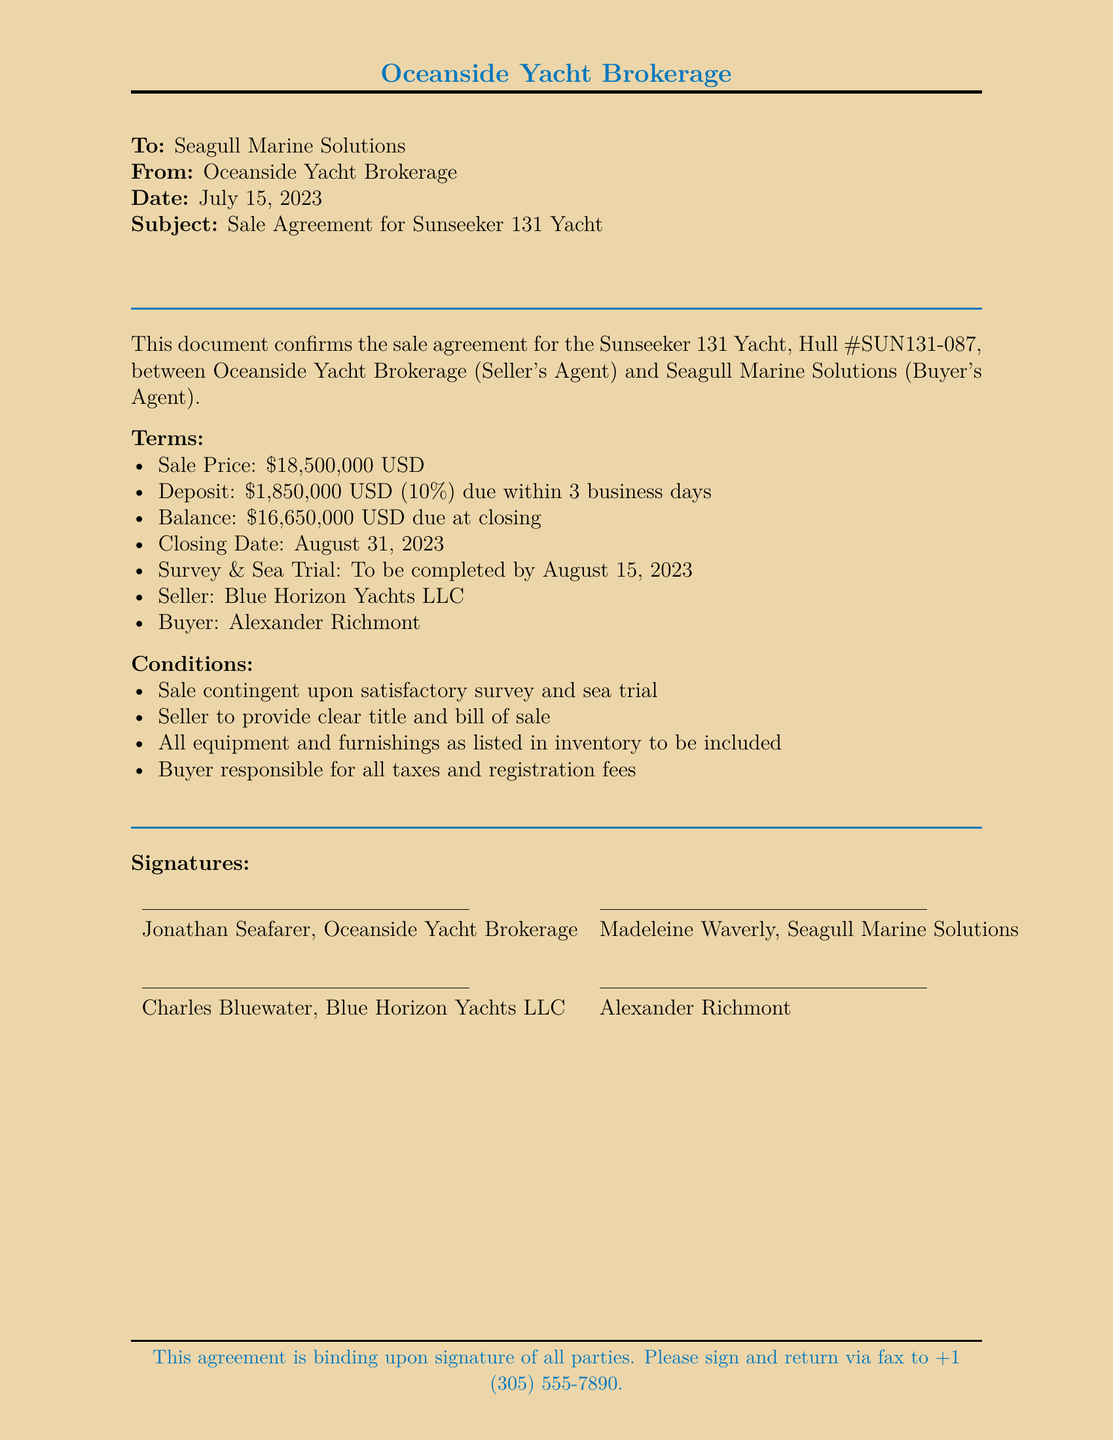What is the sale price of the yacht? The sale price is explicitly stated in the terms of the agreement as the total amount for the vessel, which is $18,500,000 USD.
Answer: $18,500,000 USD What is the deposit amount? The deposit amount is mentioned in the terms as 10% of the sale price, which totals $1,850,000 USD.
Answer: $1,850,000 USD Who is the seller's representative? The document lists Jonathan Seafarer as the representative of Oceanside Yacht Brokerage, the seller's agent.
Answer: Jonathan Seafarer What date is the closing scheduled for? The closing date is specified in the terms, indicating when the finalization of the sale is to take place.
Answer: August 31, 2023 What is the name of the buyer? The buyer is specifically named in the agreement, identifying who is purchasing the yacht.
Answer: Alexander Richmont What condition must be met before the sale is finalized? The document states that the sale is contingent upon the satisfactory outcome of both the survey and the sea trial.
Answer: Satisfactory survey and sea trial Which company is providing the yacht? The seller is explicitly identified in the document, indicating the name of the company that owns the yacht being sold.
Answer: Blue Horizon Yachts LLC What is the due date for the deposit? The terms indicate a specific time frame within which the deposit must be made following the agreement terms, specified in business days.
Answer: 3 business days What type of document is this? This document serves as a binding contract between the buyer and seller regarding the sale of the yacht, confirming all stated terms and conditions.
Answer: Sale Agreement 